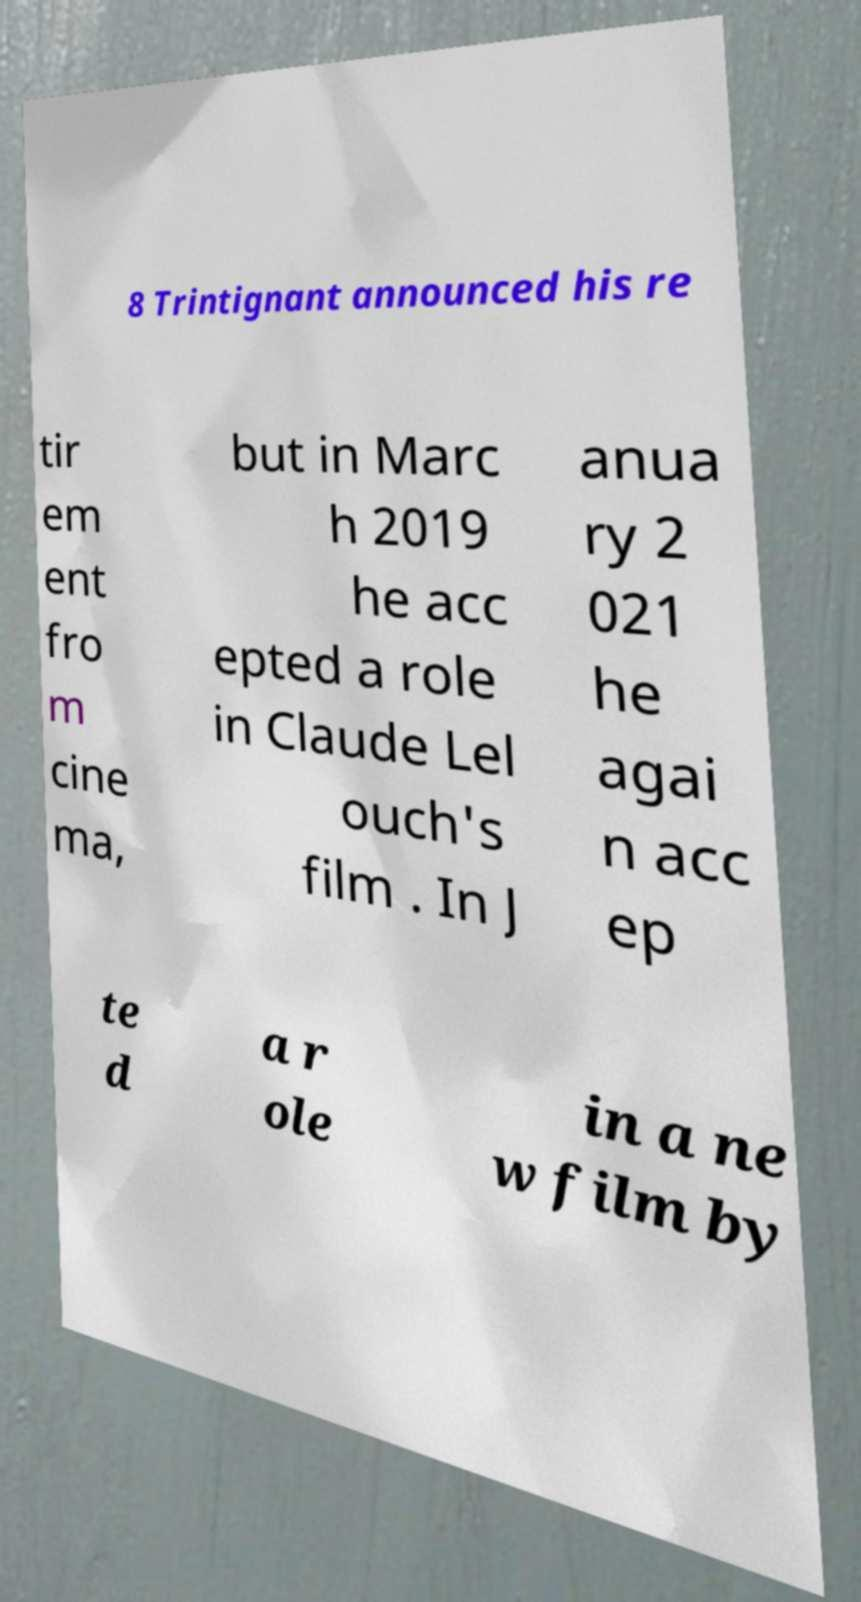What messages or text are displayed in this image? I need them in a readable, typed format. 8 Trintignant announced his re tir em ent fro m cine ma, but in Marc h 2019 he acc epted a role in Claude Lel ouch's film . In J anua ry 2 021 he agai n acc ep te d a r ole in a ne w film by 